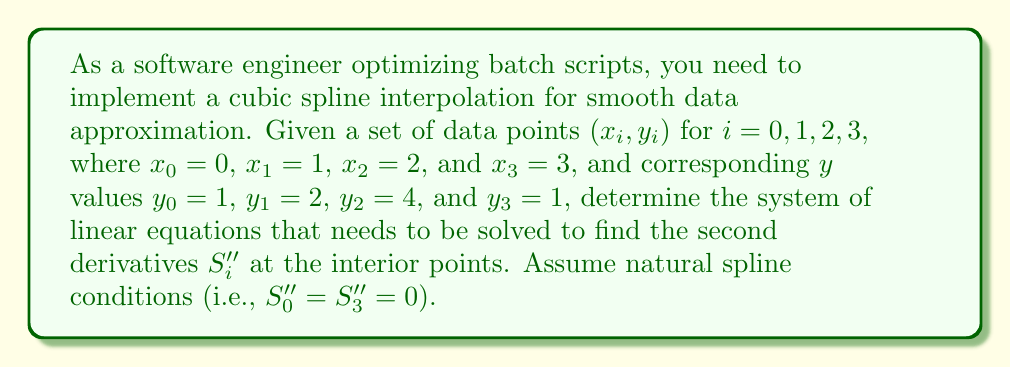Give your solution to this math problem. To design a cubic spline interpolation scheme, we need to follow these steps:

1) For $n+1$ data points, we have $n$ intervals. In this case, we have 4 points, so $n = 3$.

2) The general form of a cubic spline on the $i$-th interval $[x_i, x_{i+1}]$ is:

   $$S_i(x) = a_i + b_i(x-x_i) + c_i(x-x_i)^2 + d_i(x-x_i)^3$$

3) For natural spline conditions, we set $S_0'' = S_3'' = 0$.

4) For interior points, we need to solve for $S_i''$ values. The system of equations for interior points is:

   $$\frac{x_{i+1}-x_i}{6}S_i'' + \frac{x_{i+1}-x_{i-1}}{3}S_i'' + \frac{x_i-x_{i-1}}{6}S_{i+1}'' = \frac{y_{i+1}-y_i}{x_{i+1}-x_i} - \frac{y_i-y_{i-1}}{x_i-x_{i-1}}$$

5) In our case, we have only one interior point $(x_1, y_1)$, so we need to set up one equation:

   $$\frac{x_2-x_1}{6}S_1'' + \frac{x_2-x_0}{3}S_1'' + \frac{x_1-x_0}{6}S_2'' = \frac{y_2-y_1}{x_2-x_1} - \frac{y_1-y_0}{x_1-x_0}$$

6) Substituting the given values:

   $$\frac{2-1}{6}S_1'' + \frac{2-0}{3}S_1'' + \frac{1-0}{6}S_2'' = \frac{4-2}{2-1} - \frac{2-1}{1-0}$$

7) Simplifying:

   $$\frac{1}{6}S_1'' + \frac{2}{3}S_1'' + \frac{1}{6}S_2'' = 2 - 1$$

8) Further simplifying:

   $$\frac{5}{6}S_1'' + \frac{1}{6}S_2'' = 1$$

This is the linear equation that needs to be solved along with the natural spline conditions to find the second derivatives.
Answer: $$\frac{5}{6}S_1'' + \frac{1}{6}S_2'' = 1$$ 